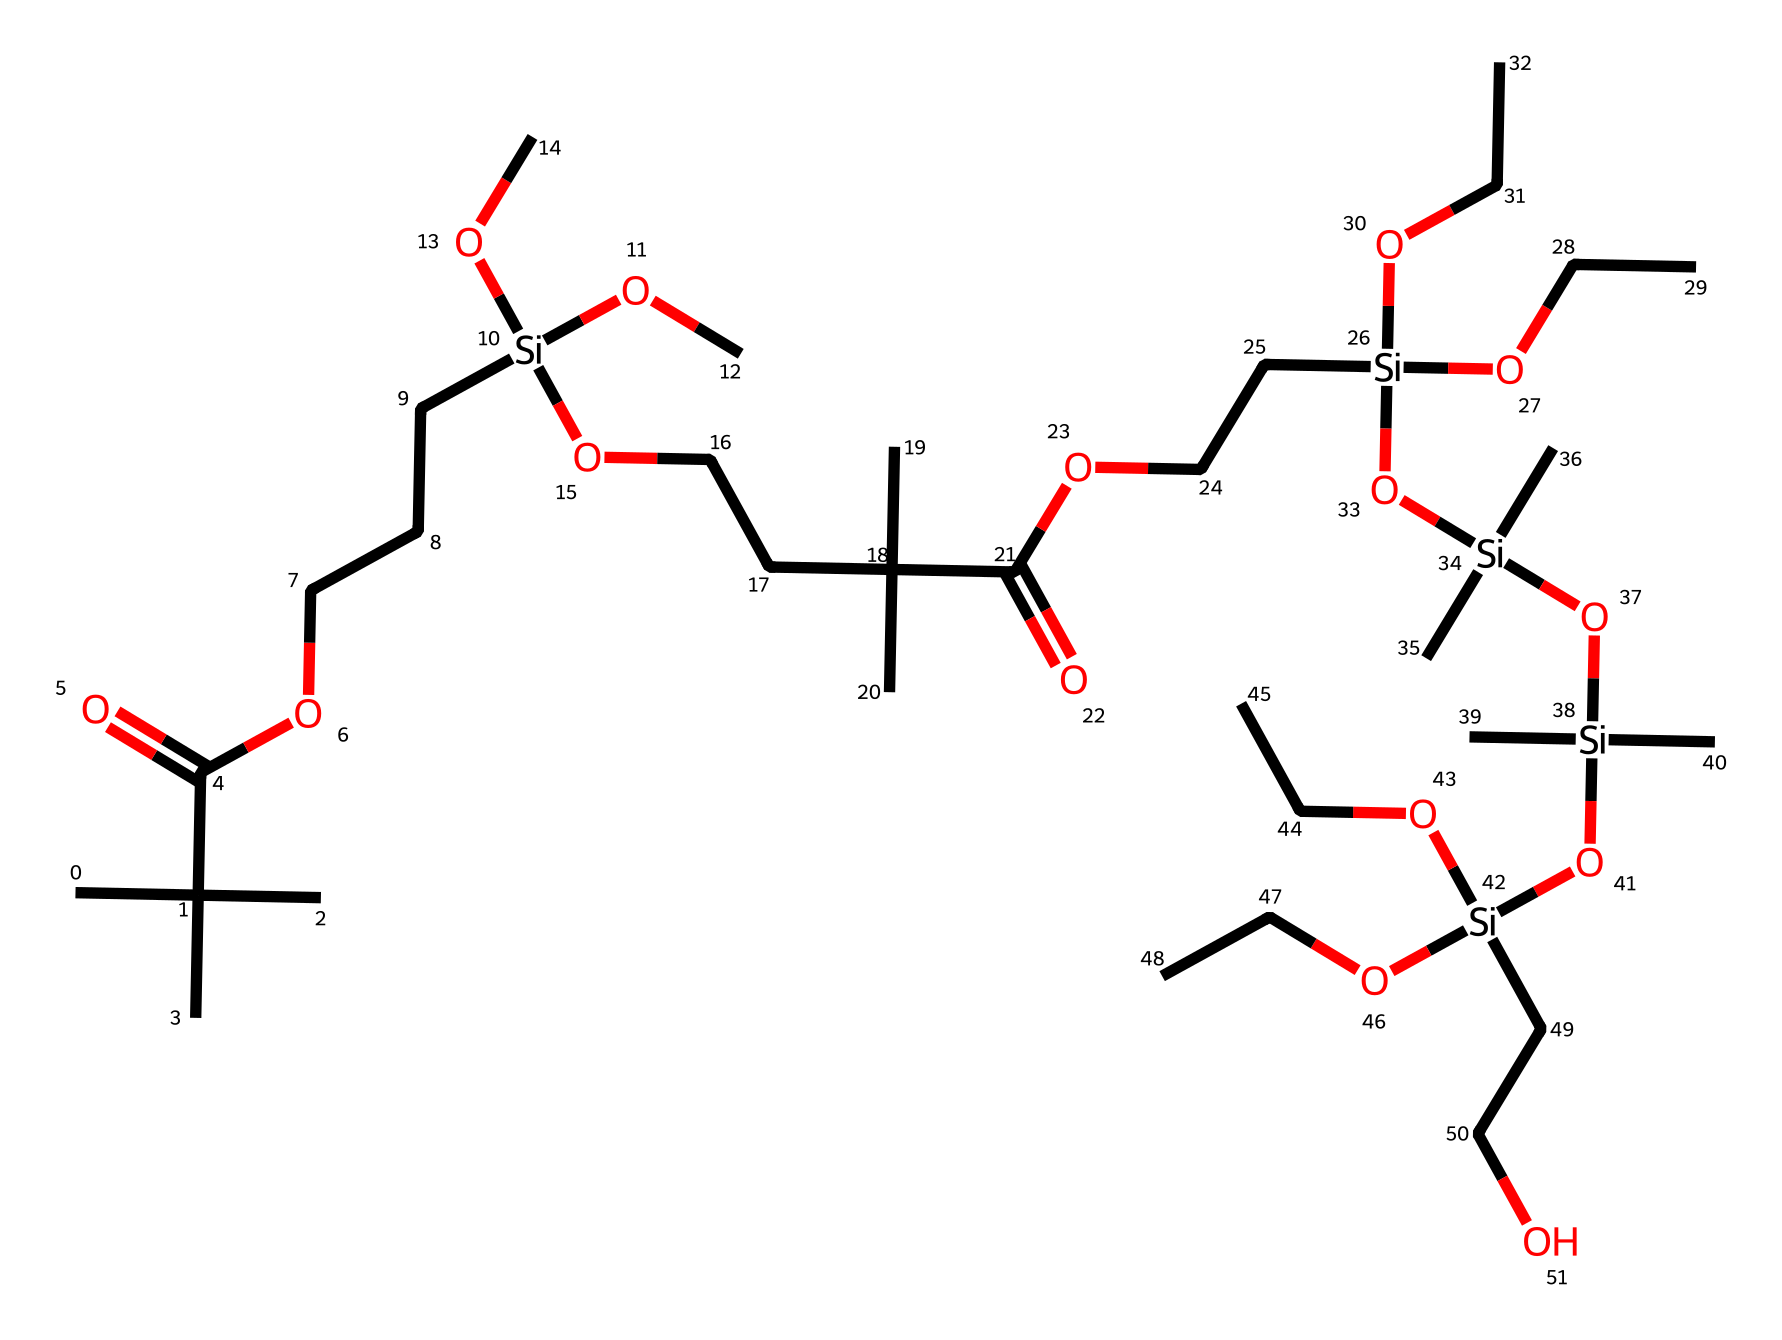What is the main functional group in this chemical structure? The chemical features carboxylic acid groups (indicated by the -C(=O)O- segment) as the prevalent functional groups.
Answer: carboxylic acid How many silicon atoms are present in the chemical? By analyzing the SMILES representation, I can count four instances of [Si] which indicate there are four silicon atoms.
Answer: four What types of substituents are attached to the silicon atoms? Each silicon atom is connected to three alkoxy groups (indicated by -OCC), confirming the presence of alkoxy substituents.
Answer: alkoxy What element predominantly characterizes this silane-modified polymer? The backbone of this polymer primarily consists of carbon atoms (C), which dominate its structure in the SMILES notation.
Answer: carbon How does this polymer contribute to the performance of kayak hull coatings? The silane-modified structure provides improved water resistance and adhesion, making it suitable for high-performance coatings.
Answer: adhesion 